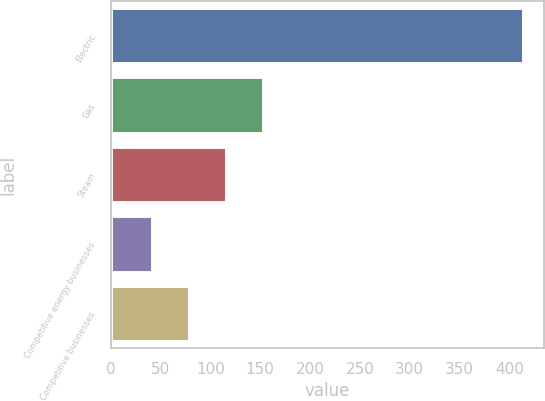Convert chart to OTSL. <chart><loc_0><loc_0><loc_500><loc_500><bar_chart><fcel>Electric<fcel>Gas<fcel>Steam<fcel>Competitive energy businesses<fcel>Competitive businesses<nl><fcel>414<fcel>152.9<fcel>115.6<fcel>41<fcel>78.3<nl></chart> 